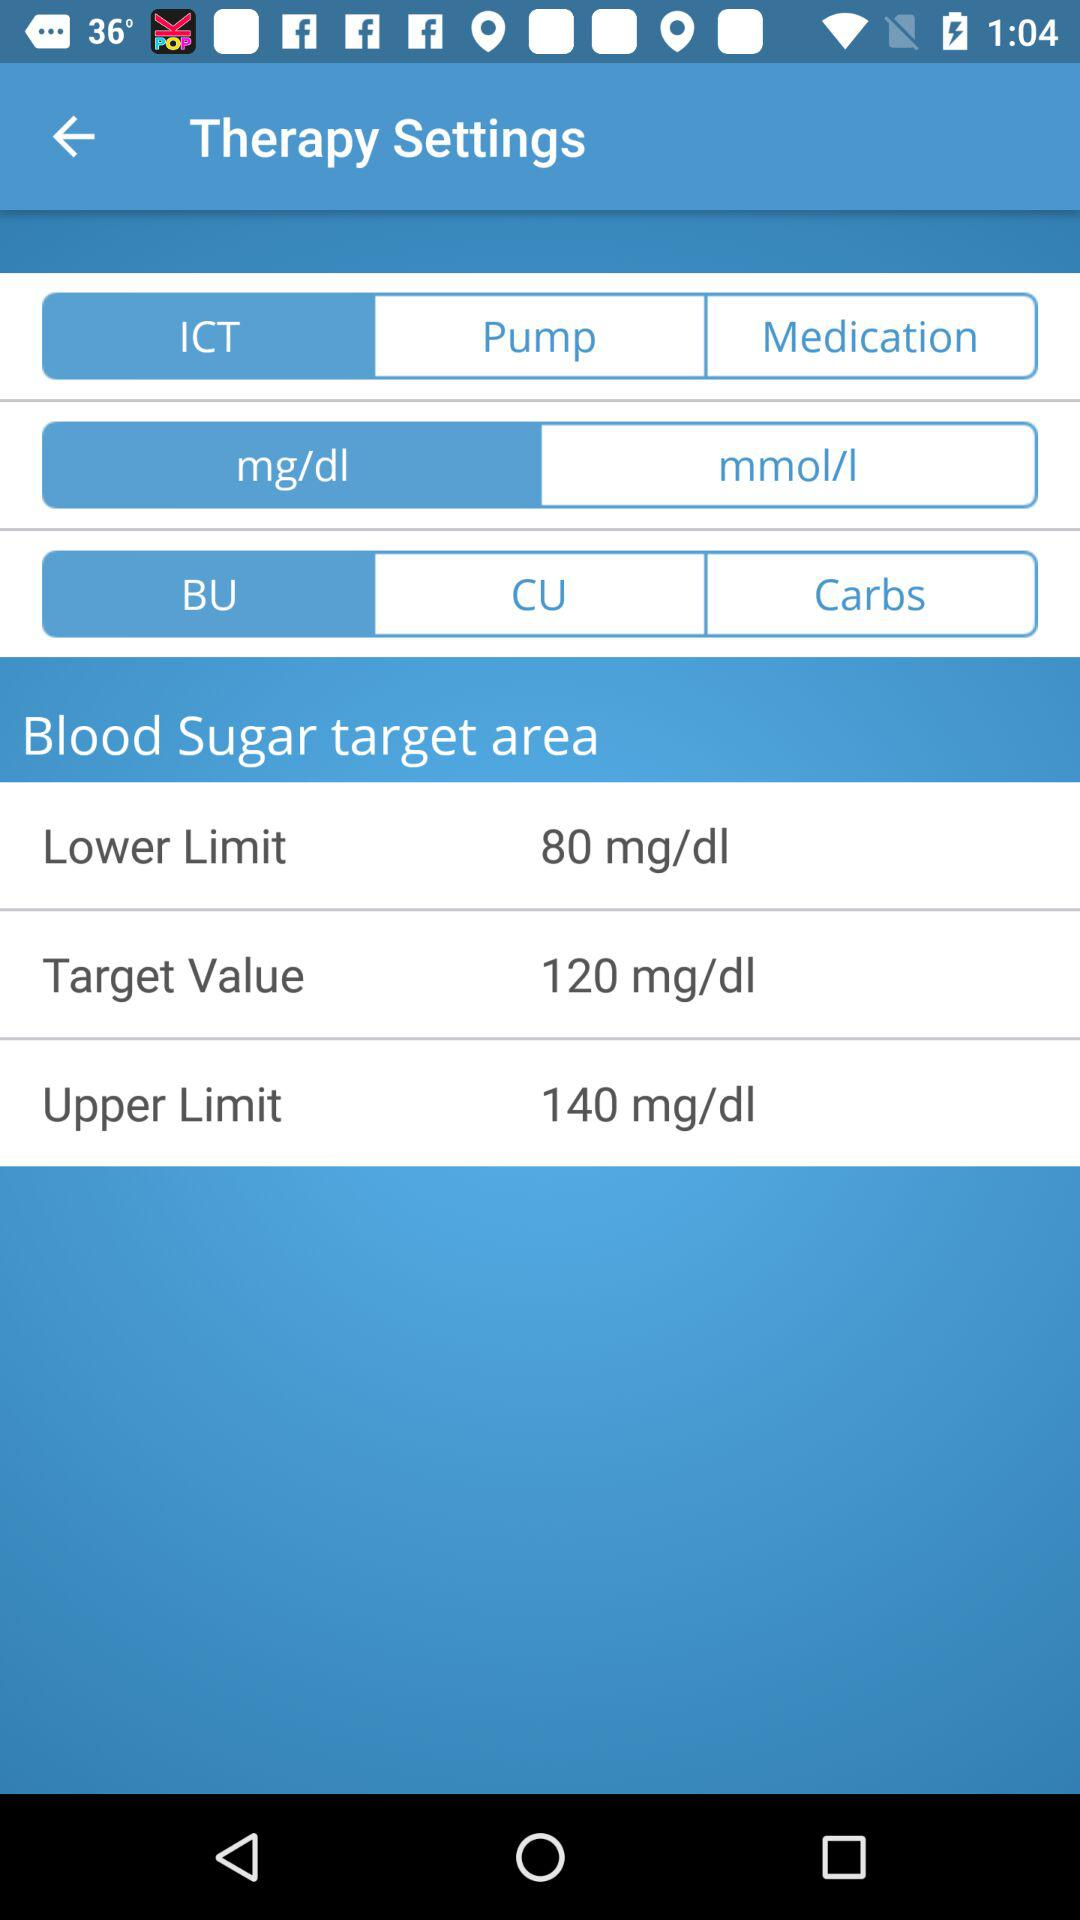What is the lower limit of blood sugar? The lower limit is 80 mg/dl. 